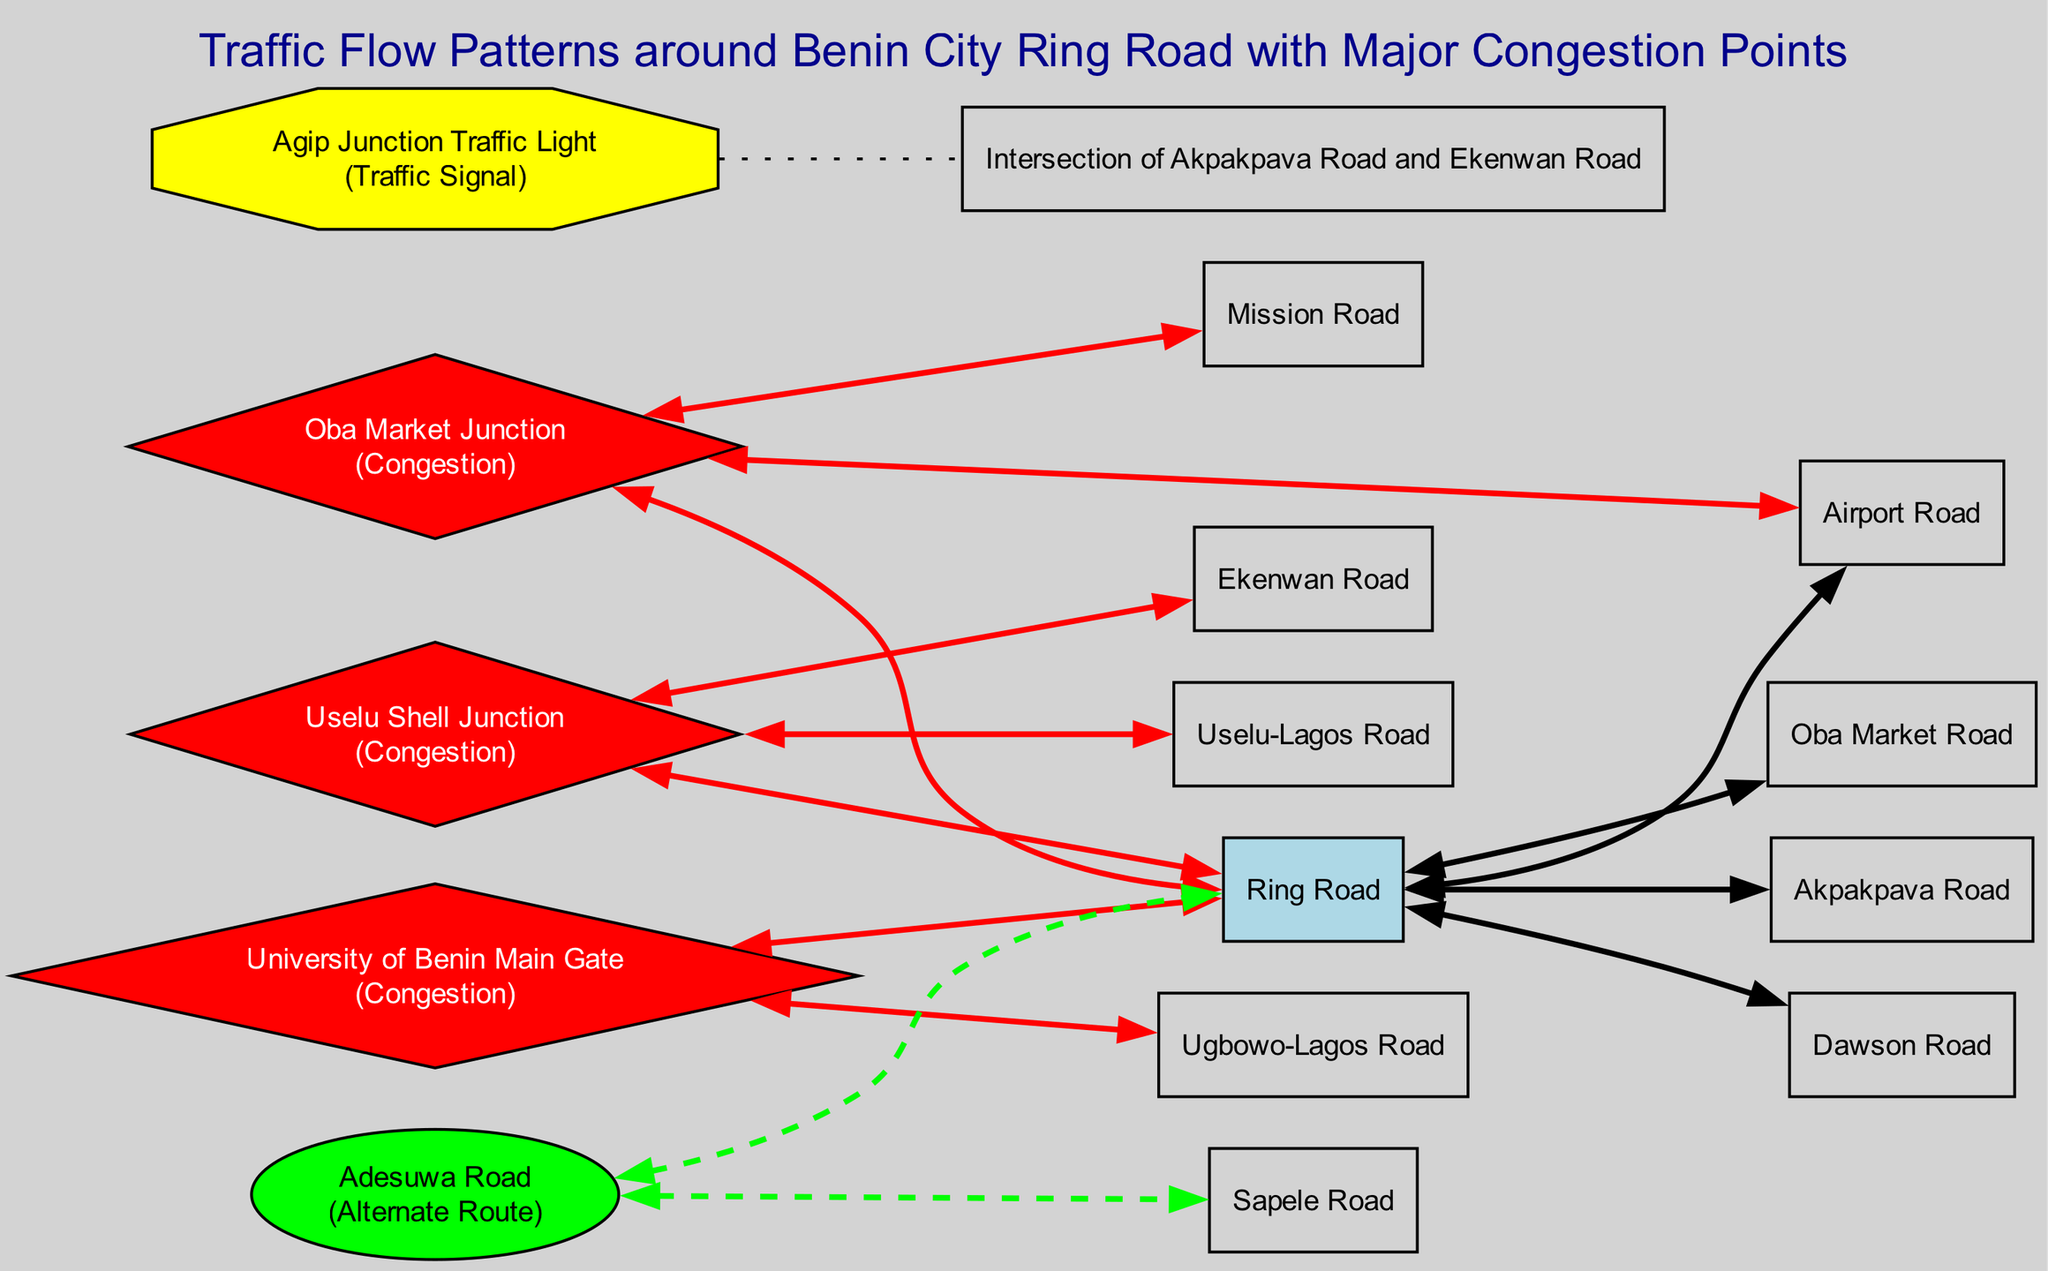What is the central road connecting major parts of Benin City? The diagram clearly labels a road segment called "Ring Road", which is described as the central circular road connecting major parts of Benin City.
Answer: Ring Road Which junction is recognized for heavy traffic congestion during market hours? The diagram specifies "Oba Market Junction" as a major intersection known for heavy traffic congestion, especially during market hours.
Answer: Oba Market Junction How many congestion points are indicated in the diagram? By counting the elements categorized as "CongestionPoint" in the diagram, we find three: Oba Market Junction, Uselu Shell Junction, and University of Benin Main Gate, resulting in a total of three congestion points.
Answer: 3 What color represents the Traffic Signal nodes in the diagram? The diagram shows that the Traffic Signal nodes, specifically "Agip Junction Traffic Light", are represented in yellow, indicating their classification.
Answer: Yellow What is the alternate route mentioned in the diagram to bypass congestion on the Ring Road? The diagram identifies "Adesuwa Road" as an alternate bypass route that is specifically noted for providing an alternative to avoid heavy congestion on the Ring Road.
Answer: Adesuwa Road Which road does the "Uselu Shell Junction" connect to other than the Ring Road? The diagram lists "Uselu Shell Junction" as being connected to "Uselu-Lagos Road" and "Ekenwan Road" in addition to the Ring Road. Thus, besides the Ring Road, Uselu Shell Junction connects to Uselu-Lagos Road and Ekenwan Road.
Answer: Uselu-Lagos Road and Ekenwan Road Where is the "Agip Junction Traffic Light" located? The location of the "Agip Junction Traffic Light" is specified in the diagram as the intersection of Akpakpava Road and Ekenwan Road.
Answer: Intersection of Akpakpava Road and Ekenwan Road Which congestion point is linked to the start and end of school hours? The "University of Benin Main Gate" is explicitly noted in the diagram to be a high congestion point during start and close of school hours, making it the answer to the question.
Answer: University of Benin Main Gate How are the alternate routes represented in the diagram? Alternate routes in the diagram are represented as "ellipse" shaped nodes, and "Adesuwa Road" is one of the examples that showcases this representation style.
Answer: Ellipse 